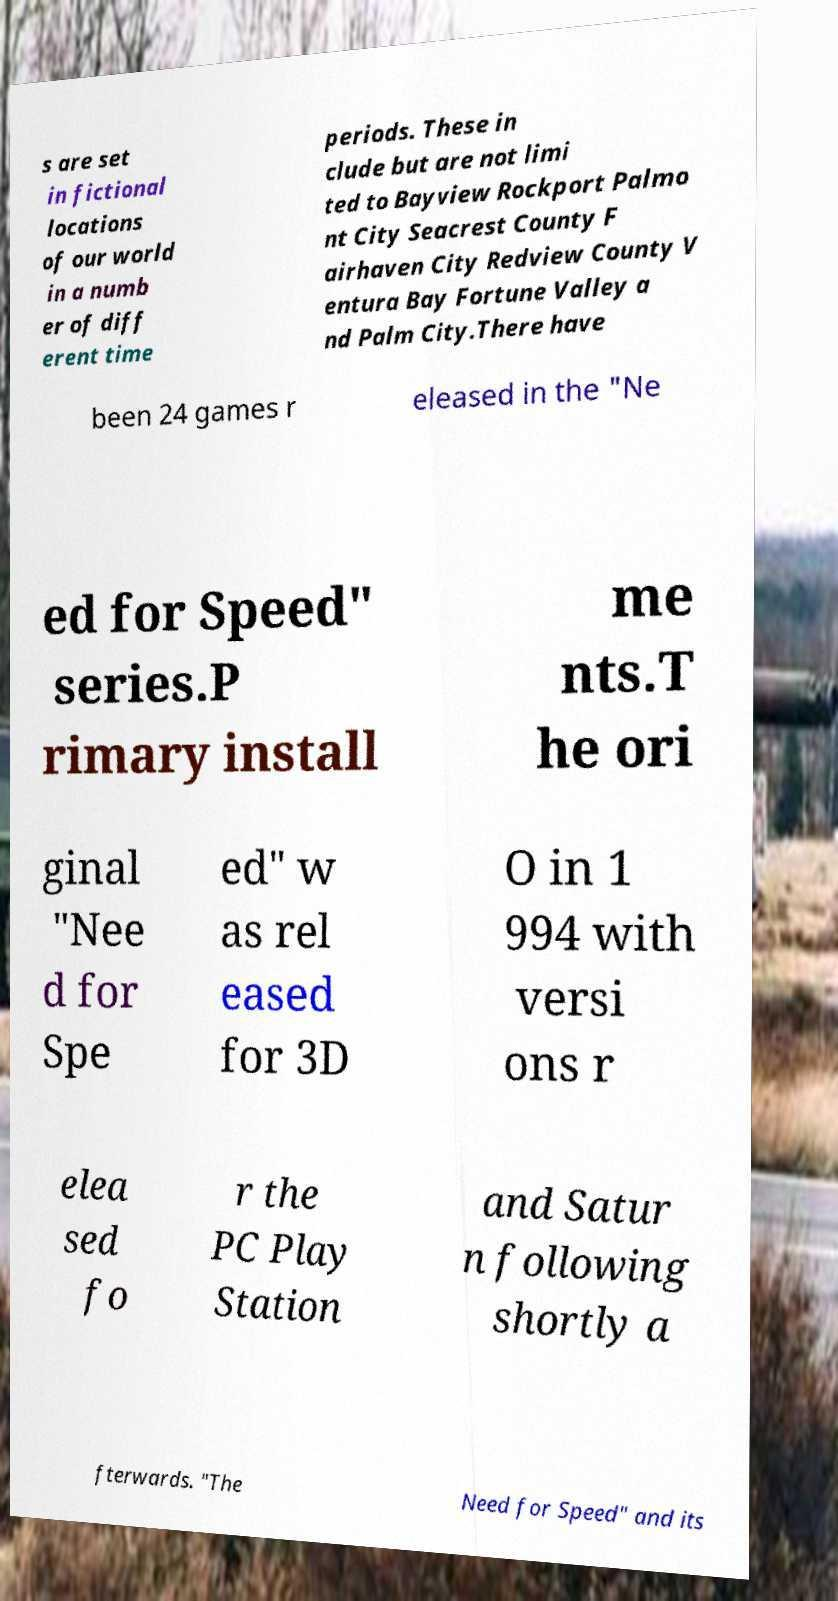Could you extract and type out the text from this image? s are set in fictional locations of our world in a numb er of diff erent time periods. These in clude but are not limi ted to Bayview Rockport Palmo nt City Seacrest County F airhaven City Redview County V entura Bay Fortune Valley a nd Palm City.There have been 24 games r eleased in the "Ne ed for Speed" series.P rimary install me nts.T he ori ginal "Nee d for Spe ed" w as rel eased for 3D O in 1 994 with versi ons r elea sed fo r the PC Play Station and Satur n following shortly a fterwards. "The Need for Speed" and its 